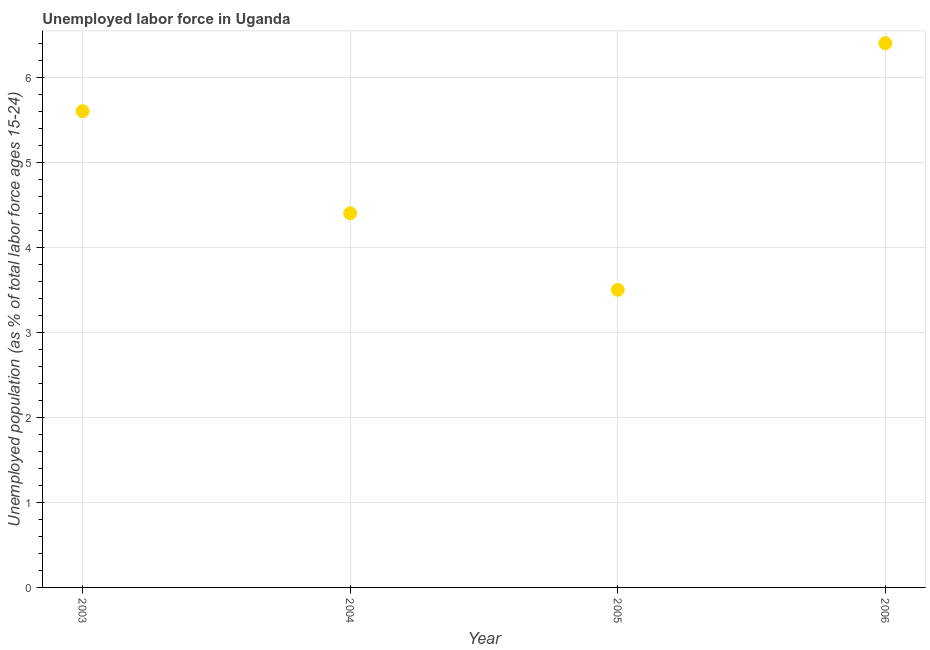What is the total unemployed youth population in 2005?
Make the answer very short. 3.5. Across all years, what is the maximum total unemployed youth population?
Offer a very short reply. 6.4. Across all years, what is the minimum total unemployed youth population?
Offer a terse response. 3.5. In which year was the total unemployed youth population maximum?
Offer a terse response. 2006. In which year was the total unemployed youth population minimum?
Offer a terse response. 2005. What is the sum of the total unemployed youth population?
Your answer should be compact. 19.9. What is the difference between the total unemployed youth population in 2003 and 2005?
Provide a short and direct response. 2.1. What is the average total unemployed youth population per year?
Ensure brevity in your answer.  4.98. What is the median total unemployed youth population?
Make the answer very short. 5. In how many years, is the total unemployed youth population greater than 5.2 %?
Your answer should be compact. 2. What is the ratio of the total unemployed youth population in 2003 to that in 2004?
Provide a succinct answer. 1.27. Is the total unemployed youth population in 2003 less than that in 2004?
Keep it short and to the point. No. What is the difference between the highest and the second highest total unemployed youth population?
Ensure brevity in your answer.  0.8. Is the sum of the total unemployed youth population in 2003 and 2004 greater than the maximum total unemployed youth population across all years?
Provide a short and direct response. Yes. What is the difference between the highest and the lowest total unemployed youth population?
Your answer should be compact. 2.9. In how many years, is the total unemployed youth population greater than the average total unemployed youth population taken over all years?
Your response must be concise. 2. Does the total unemployed youth population monotonically increase over the years?
Your answer should be very brief. No. Are the values on the major ticks of Y-axis written in scientific E-notation?
Your answer should be compact. No. Does the graph contain grids?
Keep it short and to the point. Yes. What is the title of the graph?
Offer a very short reply. Unemployed labor force in Uganda. What is the label or title of the X-axis?
Keep it short and to the point. Year. What is the label or title of the Y-axis?
Your response must be concise. Unemployed population (as % of total labor force ages 15-24). What is the Unemployed population (as % of total labor force ages 15-24) in 2003?
Provide a succinct answer. 5.6. What is the Unemployed population (as % of total labor force ages 15-24) in 2004?
Provide a succinct answer. 4.4. What is the Unemployed population (as % of total labor force ages 15-24) in 2006?
Give a very brief answer. 6.4. What is the difference between the Unemployed population (as % of total labor force ages 15-24) in 2003 and 2006?
Your response must be concise. -0.8. What is the difference between the Unemployed population (as % of total labor force ages 15-24) in 2004 and 2005?
Offer a very short reply. 0.9. What is the difference between the Unemployed population (as % of total labor force ages 15-24) in 2005 and 2006?
Your answer should be compact. -2.9. What is the ratio of the Unemployed population (as % of total labor force ages 15-24) in 2003 to that in 2004?
Your answer should be compact. 1.27. What is the ratio of the Unemployed population (as % of total labor force ages 15-24) in 2004 to that in 2005?
Ensure brevity in your answer.  1.26. What is the ratio of the Unemployed population (as % of total labor force ages 15-24) in 2004 to that in 2006?
Your answer should be very brief. 0.69. What is the ratio of the Unemployed population (as % of total labor force ages 15-24) in 2005 to that in 2006?
Your response must be concise. 0.55. 